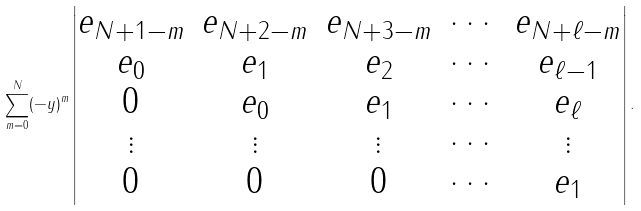<formula> <loc_0><loc_0><loc_500><loc_500>\sum _ { m = 0 } ^ { N } ( - y ) ^ { m } \begin{vmatrix} e _ { N + 1 - m } & e _ { N + 2 - m } & e _ { N + 3 - m } & \cdots & e _ { N + \ell - m } \\ e _ { 0 } & e _ { 1 } & e _ { 2 } & \cdots & e _ { \ell - 1 } \\ 0 & e _ { 0 } & e _ { 1 } & \cdots & e _ { \ell } \\ \vdots & \vdots & \vdots & \cdots & \vdots \\ 0 & 0 & 0 & \cdots & e _ { 1 } \end{vmatrix} .</formula> 